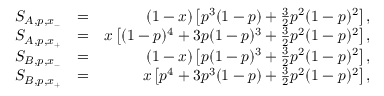Convert formula to latex. <formula><loc_0><loc_0><loc_500><loc_500>\begin{array} { r l r } { S _ { A , p , x _ { - } } } & { = } & { ( 1 - x ) \left [ p ^ { 3 } ( 1 - p ) + \frac { 3 } { 2 } p ^ { 2 } ( 1 - p ) ^ { 2 } \right ] , } \\ { S _ { A , p , x _ { + } } } & { = } & { x \left [ ( 1 - p ) ^ { 4 } + 3 p ( 1 - p ) ^ { 3 } + \frac { 3 } { 2 } p ^ { 2 } ( 1 - p ) ^ { 2 } \right ] , } \\ { S _ { B , p , x _ { - } } } & { = } & { ( 1 - x ) \left [ p ( 1 - p ) ^ { 3 } + \frac { 3 } { 2 } p ^ { 2 } ( 1 - p ) ^ { 2 } \right ] , } \\ { S _ { B , p , x _ { + } } } & { = } & { x \left [ p ^ { 4 } + 3 p ^ { 3 } ( 1 - p ) + \frac { 3 } { 2 } p ^ { 2 } ( 1 - p ) ^ { 2 } \right ] , } \end{array}</formula> 